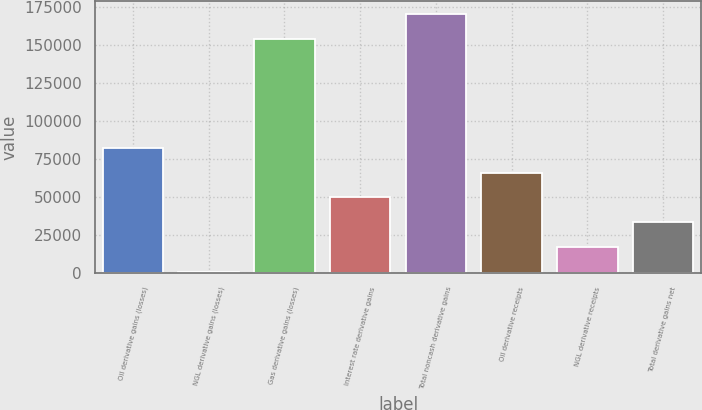Convert chart. <chart><loc_0><loc_0><loc_500><loc_500><bar_chart><fcel>Oil derivative gains (losses)<fcel>NGL derivative gains (losses)<fcel>Gas derivative gains (losses)<fcel>Interest rate derivative gains<fcel>Total noncash derivative gains<fcel>Oil derivative receipts<fcel>NGL derivative receipts<fcel>Total derivative gains net<nl><fcel>82368.5<fcel>616<fcel>153993<fcel>49667.5<fcel>170344<fcel>66018<fcel>16966.5<fcel>33317<nl></chart> 